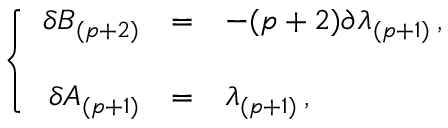Convert formula to latex. <formula><loc_0><loc_0><loc_500><loc_500>\left \{ \begin{array} { r c l } { { \delta B _ { ( p + 2 ) } } } & { = } & { { - ( p + 2 ) \partial \lambda _ { ( p + 1 ) } \, , } } \\ { { \delta A _ { ( p + 1 ) } } } & { = } & { { \lambda _ { ( p + 1 ) } \, , } } \end{array}</formula> 